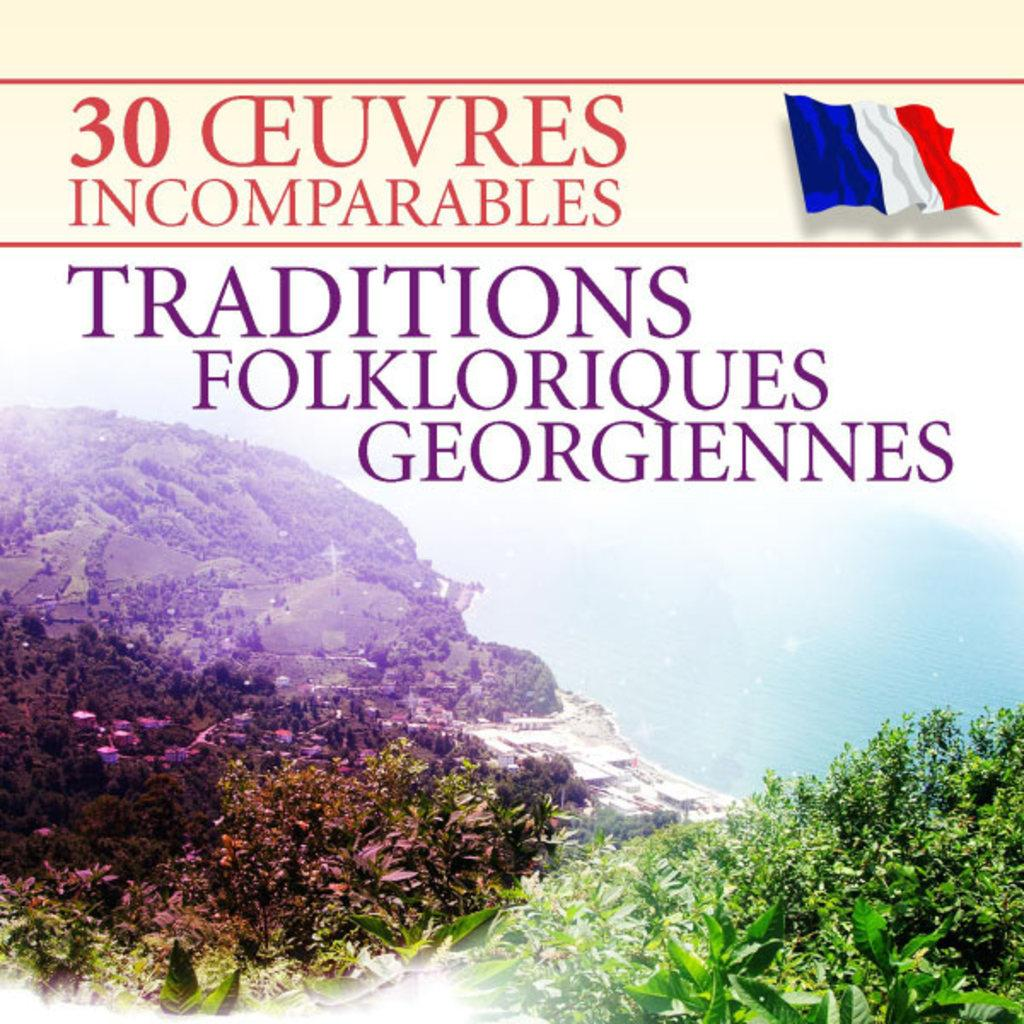<image>
Create a compact narrative representing the image presented. A book to do with French traditions and folklores. 